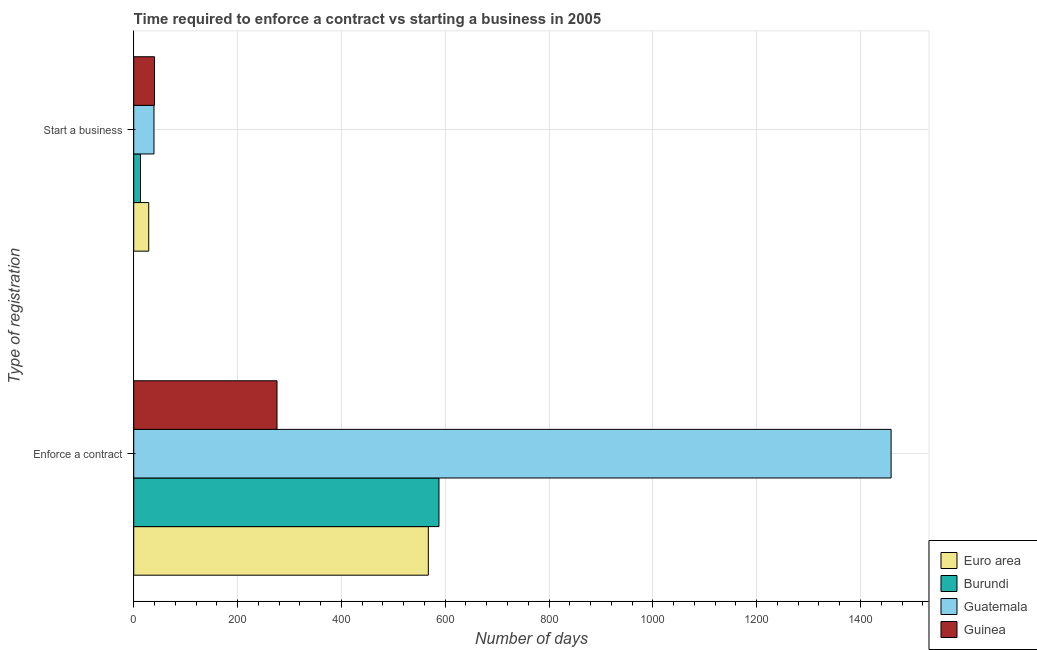How many different coloured bars are there?
Offer a very short reply. 4. Are the number of bars on each tick of the Y-axis equal?
Give a very brief answer. Yes. How many bars are there on the 2nd tick from the top?
Provide a short and direct response. 4. What is the label of the 2nd group of bars from the top?
Your answer should be very brief. Enforce a contract. What is the number of days to enforece a contract in Euro area?
Give a very brief answer. 567.5. Across all countries, what is the minimum number of days to enforece a contract?
Provide a succinct answer. 276. In which country was the number of days to enforece a contract maximum?
Provide a short and direct response. Guatemala. In which country was the number of days to enforece a contract minimum?
Offer a very short reply. Guinea. What is the total number of days to start a business in the graph?
Make the answer very short. 120.88. What is the difference between the number of days to enforece a contract in Burundi and that in Guinea?
Offer a terse response. 312. What is the difference between the number of days to enforece a contract in Euro area and the number of days to start a business in Guatemala?
Provide a succinct answer. 528.5. What is the average number of days to enforece a contract per country?
Give a very brief answer. 722.62. What is the difference between the number of days to enforece a contract and number of days to start a business in Euro area?
Provide a short and direct response. 538.62. What is the ratio of the number of days to enforece a contract in Guinea to that in Euro area?
Your answer should be very brief. 0.49. In how many countries, is the number of days to enforece a contract greater than the average number of days to enforece a contract taken over all countries?
Make the answer very short. 1. What does the 2nd bar from the top in Start a business represents?
Offer a very short reply. Guatemala. What does the 1st bar from the bottom in Enforce a contract represents?
Your answer should be very brief. Euro area. What is the difference between two consecutive major ticks on the X-axis?
Give a very brief answer. 200. Are the values on the major ticks of X-axis written in scientific E-notation?
Keep it short and to the point. No. Does the graph contain grids?
Make the answer very short. Yes. What is the title of the graph?
Provide a succinct answer. Time required to enforce a contract vs starting a business in 2005. What is the label or title of the X-axis?
Your response must be concise. Number of days. What is the label or title of the Y-axis?
Your response must be concise. Type of registration. What is the Number of days in Euro area in Enforce a contract?
Offer a terse response. 567.5. What is the Number of days of Burundi in Enforce a contract?
Your answer should be very brief. 588. What is the Number of days of Guatemala in Enforce a contract?
Offer a terse response. 1459. What is the Number of days of Guinea in Enforce a contract?
Your response must be concise. 276. What is the Number of days in Euro area in Start a business?
Offer a terse response. 28.88. What is the Number of days of Burundi in Start a business?
Keep it short and to the point. 13. What is the Number of days in Guinea in Start a business?
Give a very brief answer. 40. Across all Type of registration, what is the maximum Number of days of Euro area?
Give a very brief answer. 567.5. Across all Type of registration, what is the maximum Number of days of Burundi?
Your answer should be very brief. 588. Across all Type of registration, what is the maximum Number of days in Guatemala?
Ensure brevity in your answer.  1459. Across all Type of registration, what is the maximum Number of days in Guinea?
Keep it short and to the point. 276. Across all Type of registration, what is the minimum Number of days in Euro area?
Keep it short and to the point. 28.88. Across all Type of registration, what is the minimum Number of days of Guatemala?
Keep it short and to the point. 39. What is the total Number of days of Euro area in the graph?
Make the answer very short. 596.38. What is the total Number of days of Burundi in the graph?
Provide a short and direct response. 601. What is the total Number of days in Guatemala in the graph?
Offer a very short reply. 1498. What is the total Number of days in Guinea in the graph?
Ensure brevity in your answer.  316. What is the difference between the Number of days of Euro area in Enforce a contract and that in Start a business?
Provide a succinct answer. 538.62. What is the difference between the Number of days in Burundi in Enforce a contract and that in Start a business?
Your answer should be compact. 575. What is the difference between the Number of days in Guatemala in Enforce a contract and that in Start a business?
Make the answer very short. 1420. What is the difference between the Number of days in Guinea in Enforce a contract and that in Start a business?
Give a very brief answer. 236. What is the difference between the Number of days in Euro area in Enforce a contract and the Number of days in Burundi in Start a business?
Ensure brevity in your answer.  554.5. What is the difference between the Number of days of Euro area in Enforce a contract and the Number of days of Guatemala in Start a business?
Your response must be concise. 528.5. What is the difference between the Number of days in Euro area in Enforce a contract and the Number of days in Guinea in Start a business?
Your response must be concise. 527.5. What is the difference between the Number of days in Burundi in Enforce a contract and the Number of days in Guatemala in Start a business?
Your response must be concise. 549. What is the difference between the Number of days of Burundi in Enforce a contract and the Number of days of Guinea in Start a business?
Your answer should be very brief. 548. What is the difference between the Number of days of Guatemala in Enforce a contract and the Number of days of Guinea in Start a business?
Your answer should be very brief. 1419. What is the average Number of days in Euro area per Type of registration?
Make the answer very short. 298.19. What is the average Number of days in Burundi per Type of registration?
Keep it short and to the point. 300.5. What is the average Number of days of Guatemala per Type of registration?
Ensure brevity in your answer.  749. What is the average Number of days of Guinea per Type of registration?
Your response must be concise. 158. What is the difference between the Number of days in Euro area and Number of days in Burundi in Enforce a contract?
Provide a short and direct response. -20.5. What is the difference between the Number of days of Euro area and Number of days of Guatemala in Enforce a contract?
Your answer should be very brief. -891.5. What is the difference between the Number of days in Euro area and Number of days in Guinea in Enforce a contract?
Keep it short and to the point. 291.5. What is the difference between the Number of days in Burundi and Number of days in Guatemala in Enforce a contract?
Your answer should be compact. -871. What is the difference between the Number of days in Burundi and Number of days in Guinea in Enforce a contract?
Provide a succinct answer. 312. What is the difference between the Number of days of Guatemala and Number of days of Guinea in Enforce a contract?
Keep it short and to the point. 1183. What is the difference between the Number of days in Euro area and Number of days in Burundi in Start a business?
Provide a succinct answer. 15.88. What is the difference between the Number of days of Euro area and Number of days of Guatemala in Start a business?
Keep it short and to the point. -10.12. What is the difference between the Number of days in Euro area and Number of days in Guinea in Start a business?
Offer a terse response. -11.12. What is the difference between the Number of days in Burundi and Number of days in Guatemala in Start a business?
Your response must be concise. -26. What is the difference between the Number of days in Burundi and Number of days in Guinea in Start a business?
Your answer should be compact. -27. What is the difference between the Number of days in Guatemala and Number of days in Guinea in Start a business?
Keep it short and to the point. -1. What is the ratio of the Number of days in Euro area in Enforce a contract to that in Start a business?
Your answer should be very brief. 19.65. What is the ratio of the Number of days of Burundi in Enforce a contract to that in Start a business?
Give a very brief answer. 45.23. What is the ratio of the Number of days in Guatemala in Enforce a contract to that in Start a business?
Offer a terse response. 37.41. What is the difference between the highest and the second highest Number of days in Euro area?
Offer a terse response. 538.62. What is the difference between the highest and the second highest Number of days of Burundi?
Provide a short and direct response. 575. What is the difference between the highest and the second highest Number of days in Guatemala?
Offer a terse response. 1420. What is the difference between the highest and the second highest Number of days of Guinea?
Provide a succinct answer. 236. What is the difference between the highest and the lowest Number of days of Euro area?
Your answer should be compact. 538.62. What is the difference between the highest and the lowest Number of days of Burundi?
Your answer should be compact. 575. What is the difference between the highest and the lowest Number of days in Guatemala?
Provide a short and direct response. 1420. What is the difference between the highest and the lowest Number of days of Guinea?
Ensure brevity in your answer.  236. 